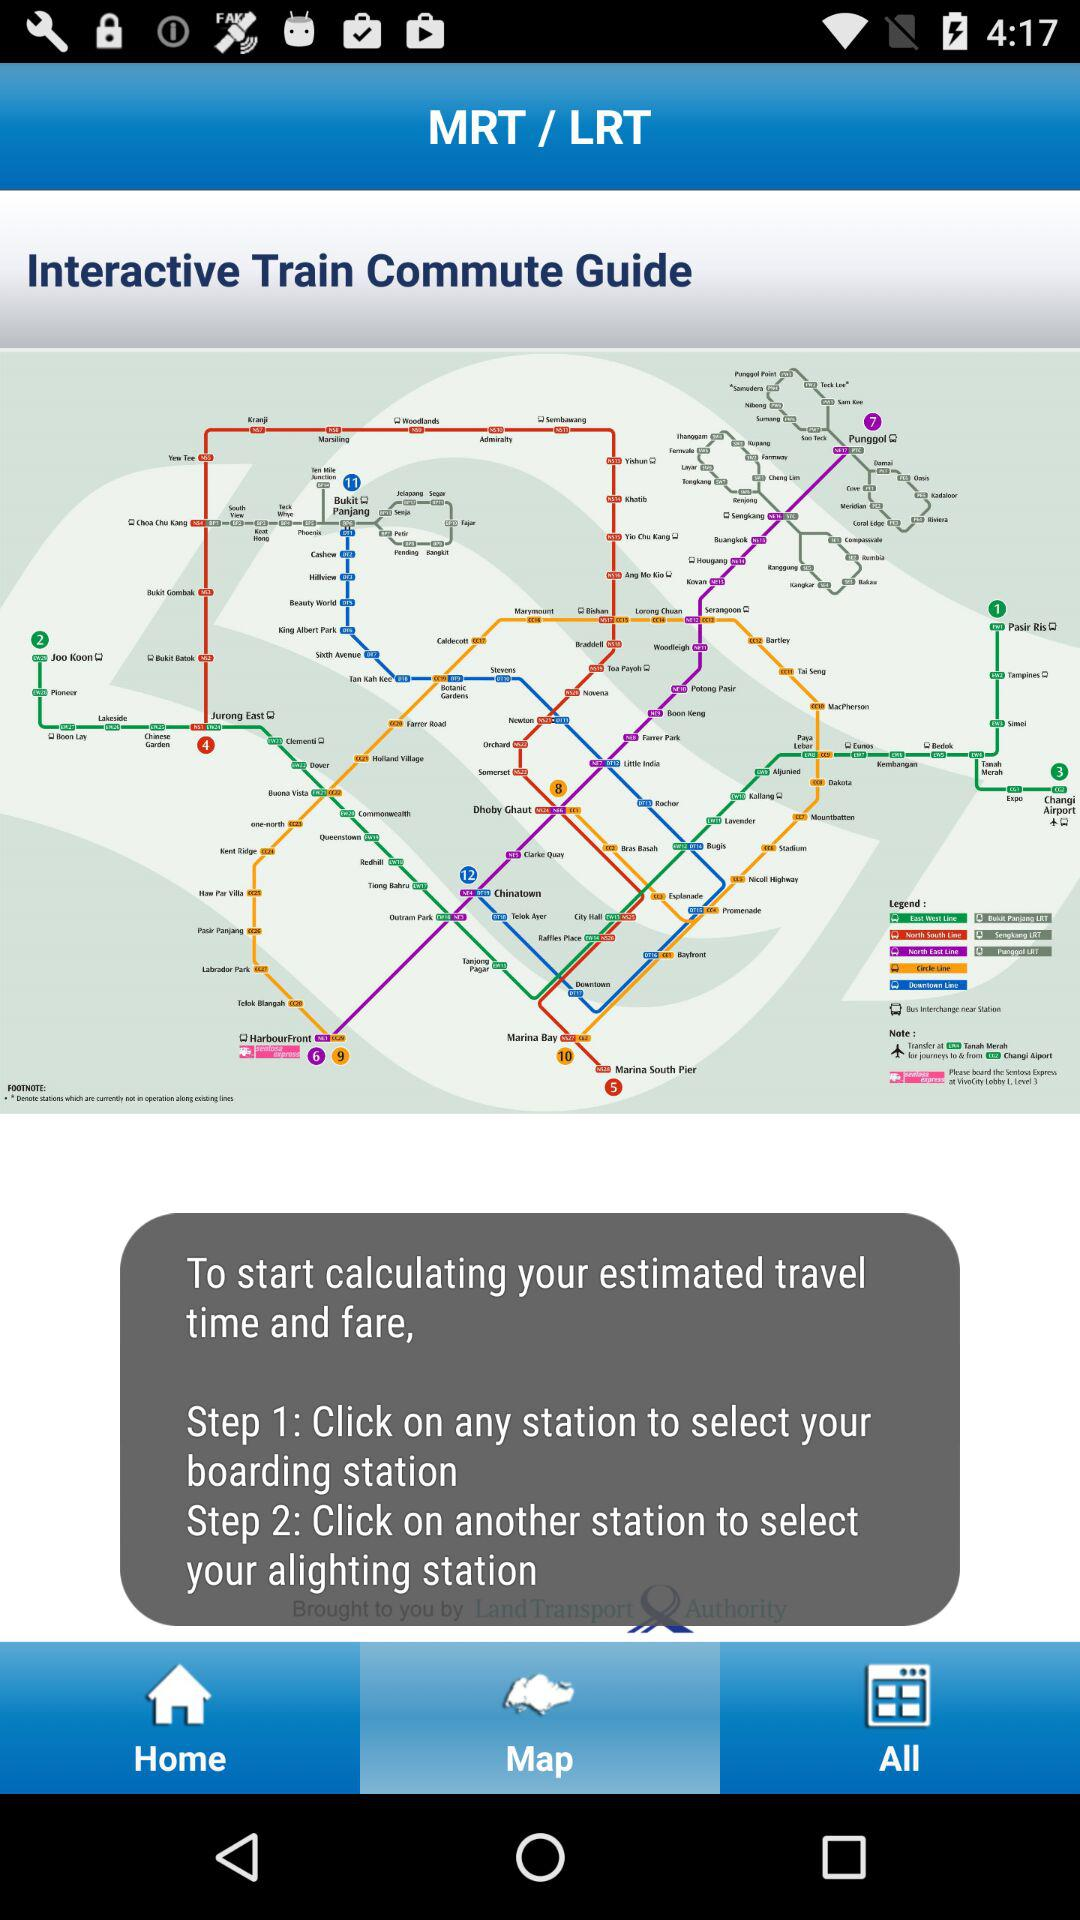What is the first step in calculating an estimated time and fare? The first step is to "Click on any station to select your boarding station". 